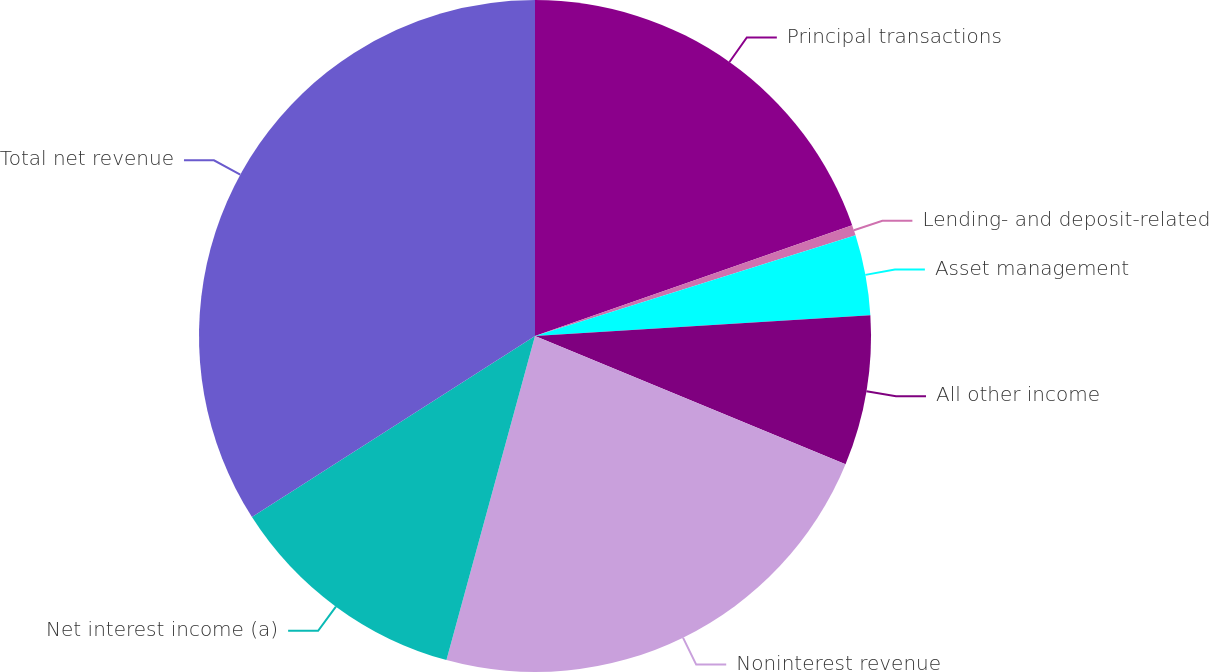Convert chart. <chart><loc_0><loc_0><loc_500><loc_500><pie_chart><fcel>Principal transactions<fcel>Lending- and deposit-related<fcel>Asset management<fcel>All other income<fcel>Noninterest revenue<fcel>Net interest income (a)<fcel>Total net revenue<nl><fcel>19.65%<fcel>0.51%<fcel>3.86%<fcel>7.22%<fcel>23.01%<fcel>11.7%<fcel>34.06%<nl></chart> 